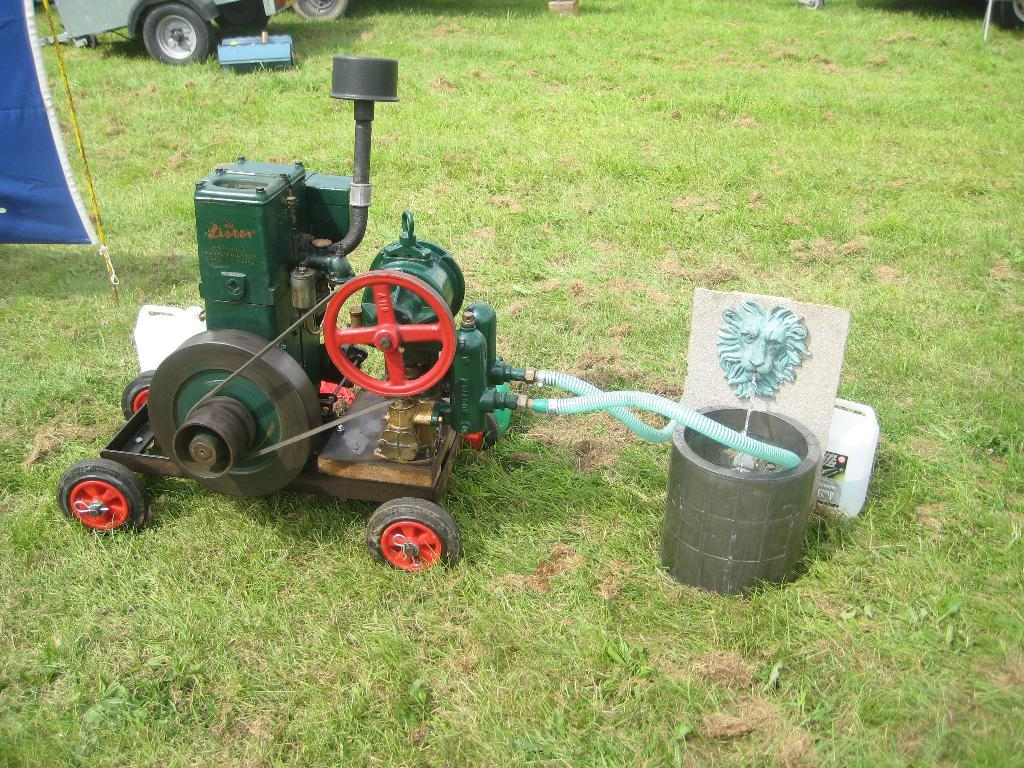What is the main subject in the picture? There is a machine in the picture. What can be seen attached to the machine? The machine has pipes attached to it. What can be seen in the background of the picture? There is a vehicle and grass visible in the background of the picture. What else is present on the ground in the background of the picture? There are other objects on the ground in the background of the picture. What type of crime is being committed in the picture? There is no crime being committed in the picture; it features a machine with pipes and a background with a vehicle, grass, and other objects. Can you see a rake being used in the picture? There is no rake present in the picture. 